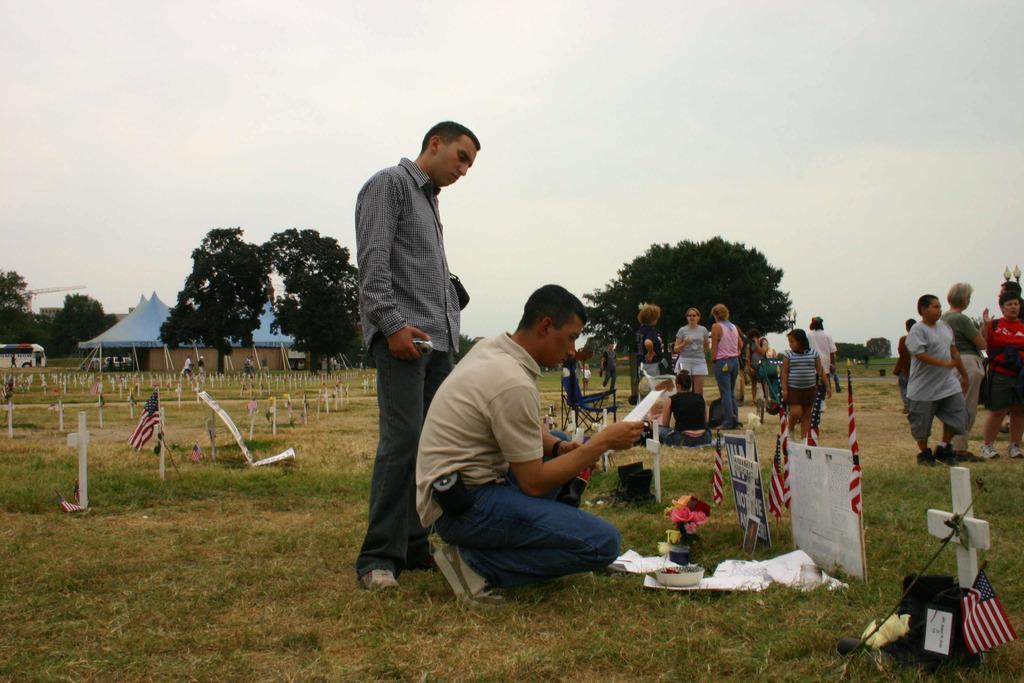In one or two sentences, can you explain what this image depicts? In this image there are a group of people some of them are standing and some of them are walking, and at the bottom there is grass. In the grass there are some flags and some cross symbols, in the background there are some trees and tents. On the top of the image there is sky. 